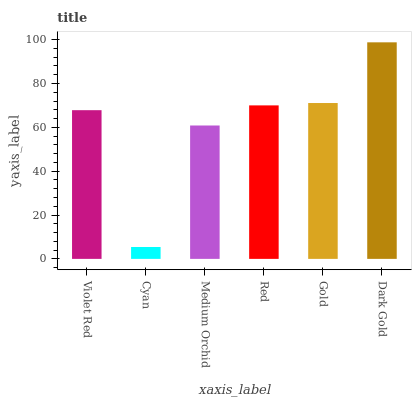Is Cyan the minimum?
Answer yes or no. Yes. Is Dark Gold the maximum?
Answer yes or no. Yes. Is Medium Orchid the minimum?
Answer yes or no. No. Is Medium Orchid the maximum?
Answer yes or no. No. Is Medium Orchid greater than Cyan?
Answer yes or no. Yes. Is Cyan less than Medium Orchid?
Answer yes or no. Yes. Is Cyan greater than Medium Orchid?
Answer yes or no. No. Is Medium Orchid less than Cyan?
Answer yes or no. No. Is Red the high median?
Answer yes or no. Yes. Is Violet Red the low median?
Answer yes or no. Yes. Is Cyan the high median?
Answer yes or no. No. Is Gold the low median?
Answer yes or no. No. 